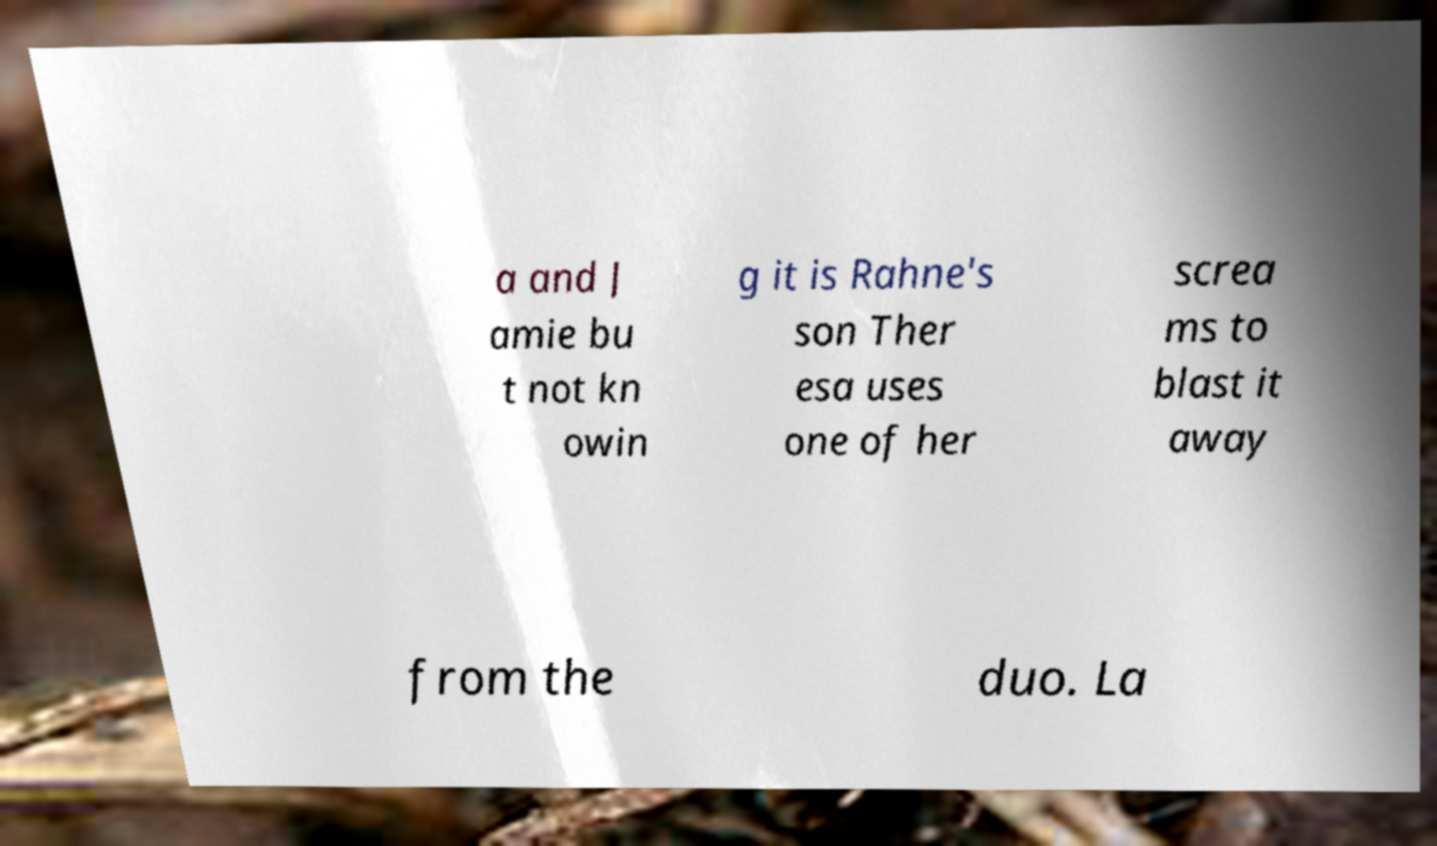Please identify and transcribe the text found in this image. a and J amie bu t not kn owin g it is Rahne's son Ther esa uses one of her screa ms to blast it away from the duo. La 